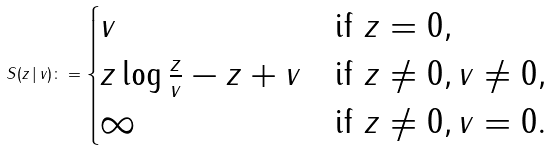Convert formula to latex. <formula><loc_0><loc_0><loc_500><loc_500>S ( z \, | \, v ) \colon = \begin{cases} v & \text {if } z = 0 , \\ z \log \frac { z } { v } - z + v & \text {if } z \neq 0 , v \neq 0 , \\ \infty & \text {if } z \neq 0 , v = 0 . \end{cases}</formula> 